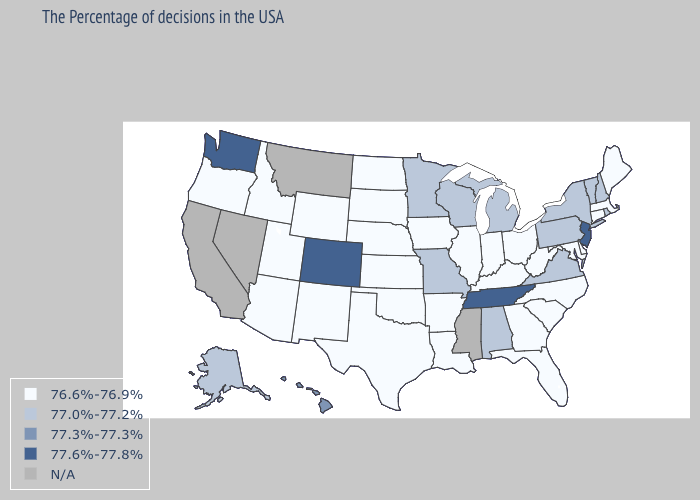Which states hav the highest value in the West?
Concise answer only. Colorado, Washington. Among the states that border Arizona , does Colorado have the lowest value?
Be succinct. No. Name the states that have a value in the range 76.6%-76.9%?
Quick response, please. Maine, Massachusetts, Connecticut, Delaware, Maryland, North Carolina, South Carolina, West Virginia, Ohio, Florida, Georgia, Kentucky, Indiana, Illinois, Louisiana, Arkansas, Iowa, Kansas, Nebraska, Oklahoma, Texas, South Dakota, North Dakota, Wyoming, New Mexico, Utah, Arizona, Idaho, Oregon. Name the states that have a value in the range 77.6%-77.8%?
Quick response, please. New Jersey, Tennessee, Colorado, Washington. Does Washington have the lowest value in the USA?
Quick response, please. No. What is the value of Maryland?
Be succinct. 76.6%-76.9%. What is the value of Delaware?
Quick response, please. 76.6%-76.9%. Name the states that have a value in the range 77.3%-77.3%?
Give a very brief answer. Hawaii. What is the value of Louisiana?
Give a very brief answer. 76.6%-76.9%. Name the states that have a value in the range 77.6%-77.8%?
Short answer required. New Jersey, Tennessee, Colorado, Washington. How many symbols are there in the legend?
Give a very brief answer. 5. Among the states that border Montana , which have the lowest value?
Concise answer only. South Dakota, North Dakota, Wyoming, Idaho. Name the states that have a value in the range 77.6%-77.8%?
Answer briefly. New Jersey, Tennessee, Colorado, Washington. What is the value of Nevada?
Give a very brief answer. N/A. 